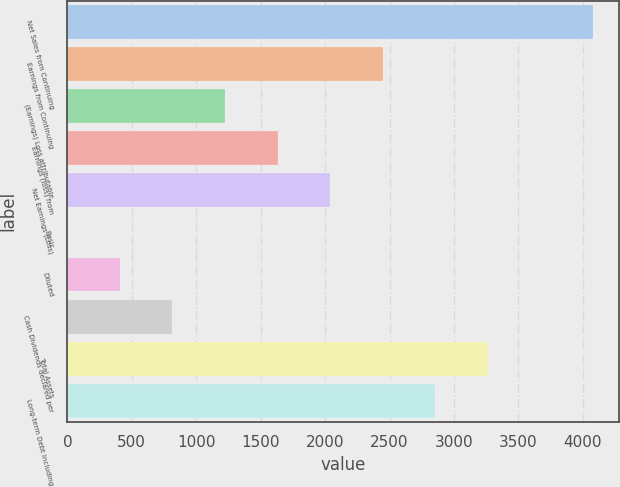<chart> <loc_0><loc_0><loc_500><loc_500><bar_chart><fcel>Net Sales from Continuing<fcel>Earnings from Continuing<fcel>(Earnings) Loss attributable<fcel>Earnings (loss) from<fcel>Net Earnings (Loss)<fcel>Basic<fcel>Diluted<fcel>Cash Dividends declared per<fcel>Total Assets<fcel>Long-term Debt including<nl><fcel>4076<fcel>2445.91<fcel>1223.32<fcel>1630.85<fcel>2038.38<fcel>0.73<fcel>408.26<fcel>815.79<fcel>3260.97<fcel>2853.44<nl></chart> 